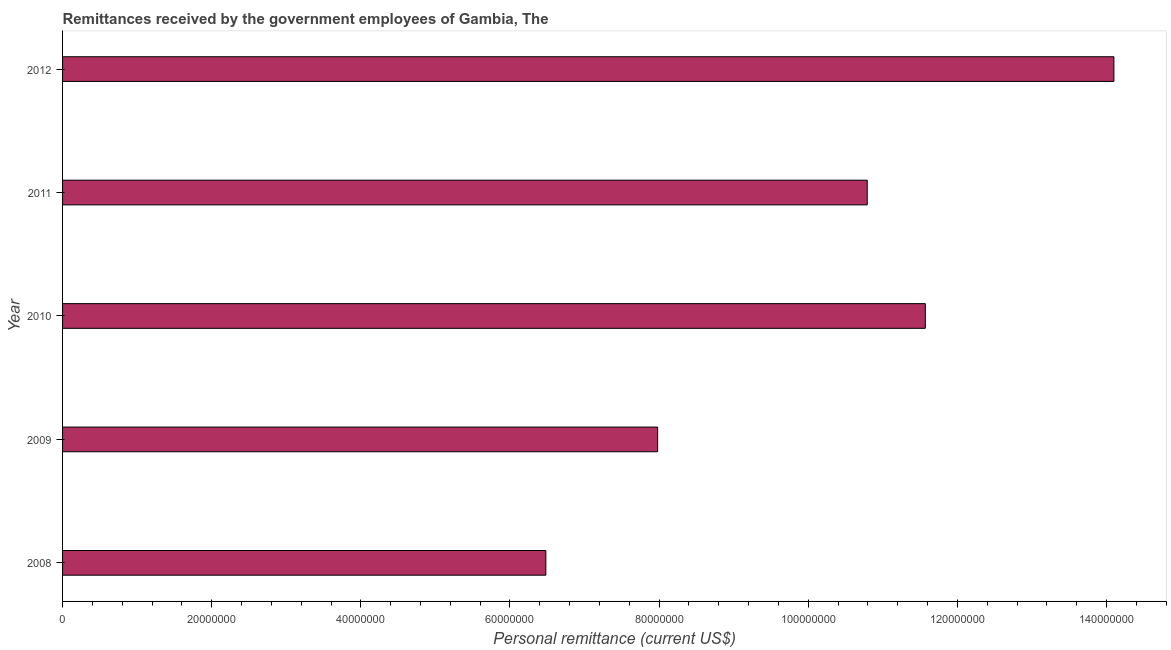Does the graph contain any zero values?
Your response must be concise. No. What is the title of the graph?
Provide a short and direct response. Remittances received by the government employees of Gambia, The. What is the label or title of the X-axis?
Your answer should be very brief. Personal remittance (current US$). What is the label or title of the Y-axis?
Your answer should be very brief. Year. What is the personal remittances in 2010?
Make the answer very short. 1.16e+08. Across all years, what is the maximum personal remittances?
Your response must be concise. 1.41e+08. Across all years, what is the minimum personal remittances?
Offer a terse response. 6.48e+07. In which year was the personal remittances minimum?
Offer a very short reply. 2008. What is the sum of the personal remittances?
Keep it short and to the point. 5.09e+08. What is the difference between the personal remittances in 2010 and 2011?
Your answer should be compact. 7.79e+06. What is the average personal remittances per year?
Your response must be concise. 1.02e+08. What is the median personal remittances?
Ensure brevity in your answer.  1.08e+08. In how many years, is the personal remittances greater than 20000000 US$?
Give a very brief answer. 5. What is the ratio of the personal remittances in 2009 to that in 2010?
Provide a short and direct response. 0.69. Is the difference between the personal remittances in 2008 and 2011 greater than the difference between any two years?
Give a very brief answer. No. What is the difference between the highest and the second highest personal remittances?
Your response must be concise. 2.53e+07. Is the sum of the personal remittances in 2009 and 2011 greater than the maximum personal remittances across all years?
Ensure brevity in your answer.  Yes. What is the difference between the highest and the lowest personal remittances?
Keep it short and to the point. 7.62e+07. How many bars are there?
Your answer should be compact. 5. Are all the bars in the graph horizontal?
Offer a terse response. Yes. Are the values on the major ticks of X-axis written in scientific E-notation?
Provide a short and direct response. No. What is the Personal remittance (current US$) of 2008?
Provide a short and direct response. 6.48e+07. What is the Personal remittance (current US$) in 2009?
Ensure brevity in your answer.  7.98e+07. What is the Personal remittance (current US$) of 2010?
Your answer should be very brief. 1.16e+08. What is the Personal remittance (current US$) of 2011?
Ensure brevity in your answer.  1.08e+08. What is the Personal remittance (current US$) of 2012?
Offer a very short reply. 1.41e+08. What is the difference between the Personal remittance (current US$) in 2008 and 2009?
Ensure brevity in your answer.  -1.50e+07. What is the difference between the Personal remittance (current US$) in 2008 and 2010?
Keep it short and to the point. -5.09e+07. What is the difference between the Personal remittance (current US$) in 2008 and 2011?
Offer a terse response. -4.31e+07. What is the difference between the Personal remittance (current US$) in 2008 and 2012?
Ensure brevity in your answer.  -7.62e+07. What is the difference between the Personal remittance (current US$) in 2009 and 2010?
Your answer should be compact. -3.59e+07. What is the difference between the Personal remittance (current US$) in 2009 and 2011?
Make the answer very short. -2.81e+07. What is the difference between the Personal remittance (current US$) in 2009 and 2012?
Give a very brief answer. -6.12e+07. What is the difference between the Personal remittance (current US$) in 2010 and 2011?
Provide a succinct answer. 7.79e+06. What is the difference between the Personal remittance (current US$) in 2010 and 2012?
Offer a terse response. -2.53e+07. What is the difference between the Personal remittance (current US$) in 2011 and 2012?
Offer a terse response. -3.31e+07. What is the ratio of the Personal remittance (current US$) in 2008 to that in 2009?
Make the answer very short. 0.81. What is the ratio of the Personal remittance (current US$) in 2008 to that in 2010?
Provide a succinct answer. 0.56. What is the ratio of the Personal remittance (current US$) in 2008 to that in 2011?
Make the answer very short. 0.6. What is the ratio of the Personal remittance (current US$) in 2008 to that in 2012?
Offer a terse response. 0.46. What is the ratio of the Personal remittance (current US$) in 2009 to that in 2010?
Your answer should be very brief. 0.69. What is the ratio of the Personal remittance (current US$) in 2009 to that in 2011?
Offer a very short reply. 0.74. What is the ratio of the Personal remittance (current US$) in 2009 to that in 2012?
Provide a succinct answer. 0.57. What is the ratio of the Personal remittance (current US$) in 2010 to that in 2011?
Keep it short and to the point. 1.07. What is the ratio of the Personal remittance (current US$) in 2010 to that in 2012?
Ensure brevity in your answer.  0.82. What is the ratio of the Personal remittance (current US$) in 2011 to that in 2012?
Provide a succinct answer. 0.77. 